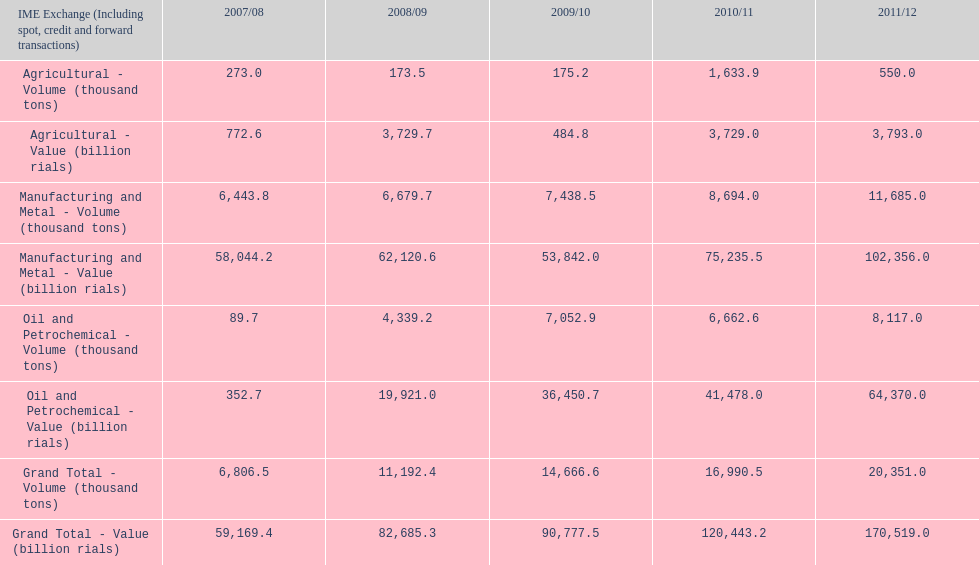During 2008/09, what was the cumulative value of the agricultural sector? 3,729.7. 